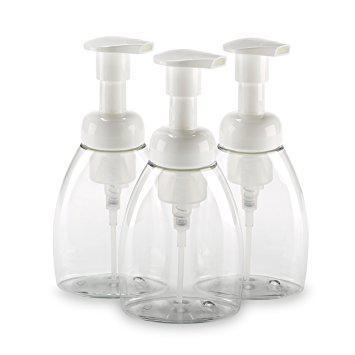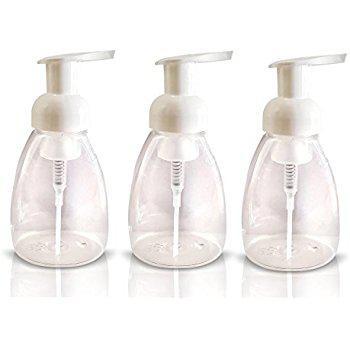The first image is the image on the left, the second image is the image on the right. Considering the images on both sides, is "The soap dispenser in the left image contains blue soap." valid? Answer yes or no. No. The first image is the image on the left, the second image is the image on the right. Considering the images on both sides, is "The right image contains a dispenser with a chrome top." valid? Answer yes or no. No. 